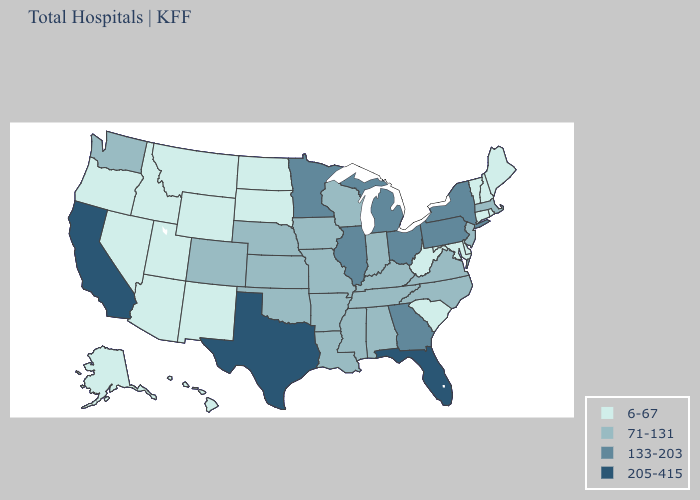Does Louisiana have the lowest value in the USA?
Short answer required. No. Does Maryland have the lowest value in the USA?
Keep it brief. Yes. What is the lowest value in states that border Massachusetts?
Keep it brief. 6-67. Among the states that border Delaware , which have the highest value?
Keep it brief. Pennsylvania. Does Maryland have the same value as California?
Concise answer only. No. Name the states that have a value in the range 133-203?
Answer briefly. Georgia, Illinois, Michigan, Minnesota, New York, Ohio, Pennsylvania. What is the lowest value in the USA?
Keep it brief. 6-67. Name the states that have a value in the range 133-203?
Short answer required. Georgia, Illinois, Michigan, Minnesota, New York, Ohio, Pennsylvania. Which states have the lowest value in the MidWest?
Answer briefly. North Dakota, South Dakota. Which states have the highest value in the USA?
Concise answer only. California, Florida, Texas. Does South Carolina have the lowest value in the USA?
Short answer required. Yes. Name the states that have a value in the range 71-131?
Give a very brief answer. Alabama, Arkansas, Colorado, Indiana, Iowa, Kansas, Kentucky, Louisiana, Massachusetts, Mississippi, Missouri, Nebraska, New Jersey, North Carolina, Oklahoma, Tennessee, Virginia, Washington, Wisconsin. Among the states that border Utah , does Colorado have the highest value?
Write a very short answer. Yes. Among the states that border Florida , does Alabama have the lowest value?
Write a very short answer. Yes. What is the value of Arkansas?
Give a very brief answer. 71-131. 